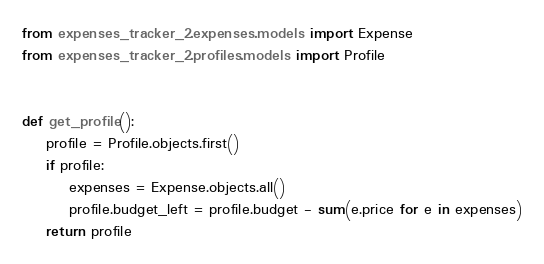Convert code to text. <code><loc_0><loc_0><loc_500><loc_500><_Python_>from expenses_tracker_2.expenses.models import Expense
from expenses_tracker_2.profiles.models import Profile


def get_profile():
    profile = Profile.objects.first()
    if profile:
        expenses = Expense.objects.all()
        profile.budget_left = profile.budget - sum(e.price for e in expenses)
    return profile
</code> 